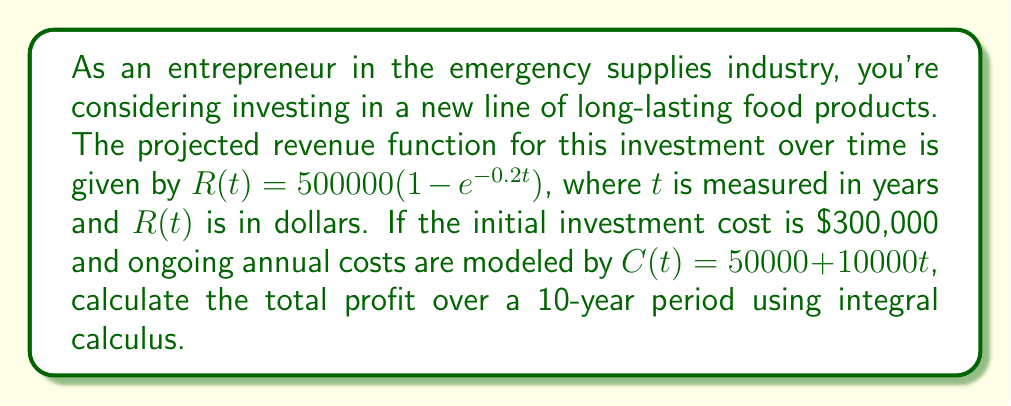Provide a solution to this math problem. To solve this problem, we need to follow these steps:

1) The profit function P(t) is the difference between revenue R(t) and costs C(t):
   
   $P(t) = R(t) - C(t) = 500000(1 - e^{-0.2t}) - (50000 + 10000t)$

2) To find the total profit over 10 years, we need to integrate P(t) from 0 to 10:

   $\text{Total Profit} = \int_0^{10} P(t) dt - 300000$

   $= \int_0^{10} [500000(1 - e^{-0.2t}) - (50000 + 10000t)] dt - 300000$

3) Let's break this integral into parts:

   $= 500000 \int_0^{10} (1 - e^{-0.2t}) dt - 50000 \int_0^{10} dt - 10000 \int_0^{10} t dt - 300000$

4) Solve each integral:

   $= 500000 [t + 5e^{-0.2t}]_0^{10} - 50000[t]_0^{10} - 10000[\frac{t^2}{2}]_0^{10} - 300000$

5) Evaluate the definite integrals:

   $= 500000 [(10 + 5e^{-2}) - (0 + 5)] - 50000(10 - 0) - 10000(\frac{100}{2} - 0) - 300000$

6) Simplify:

   $= 500000 (10 + 5e^{-2} - 5) - 500000 - 500000 - 300000$

   $= 5000000 + 2500000e^{-2} - 2500000 - 500000 - 500000 - 300000$

   $= 1200000 + 2500000e^{-2}$

7) Calculate the final value (rounded to nearest dollar):

   $= 1200000 + 2500000 * 0.1353352832366127$
   $= 1538338$
Answer: $1,538,338 